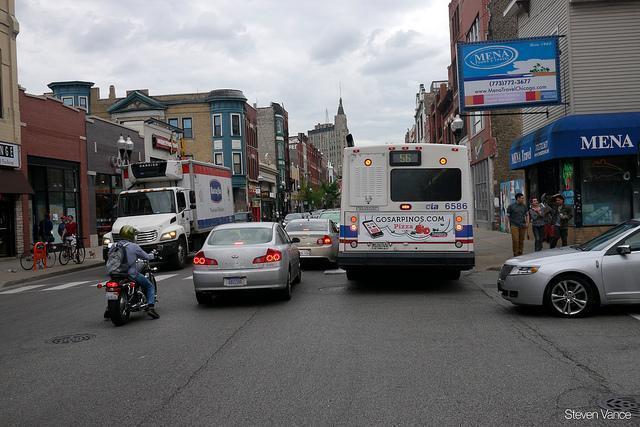Which vehicle stuck in the intersection is in the most danger?
Select the accurate answer and provide justification: `Answer: choice
Rationale: srationale.`
Options: Truck, car, bus, motorcycle. Answer: motorcycle.
Rationale: The cyclist has less to protect him than the cars on the road. 